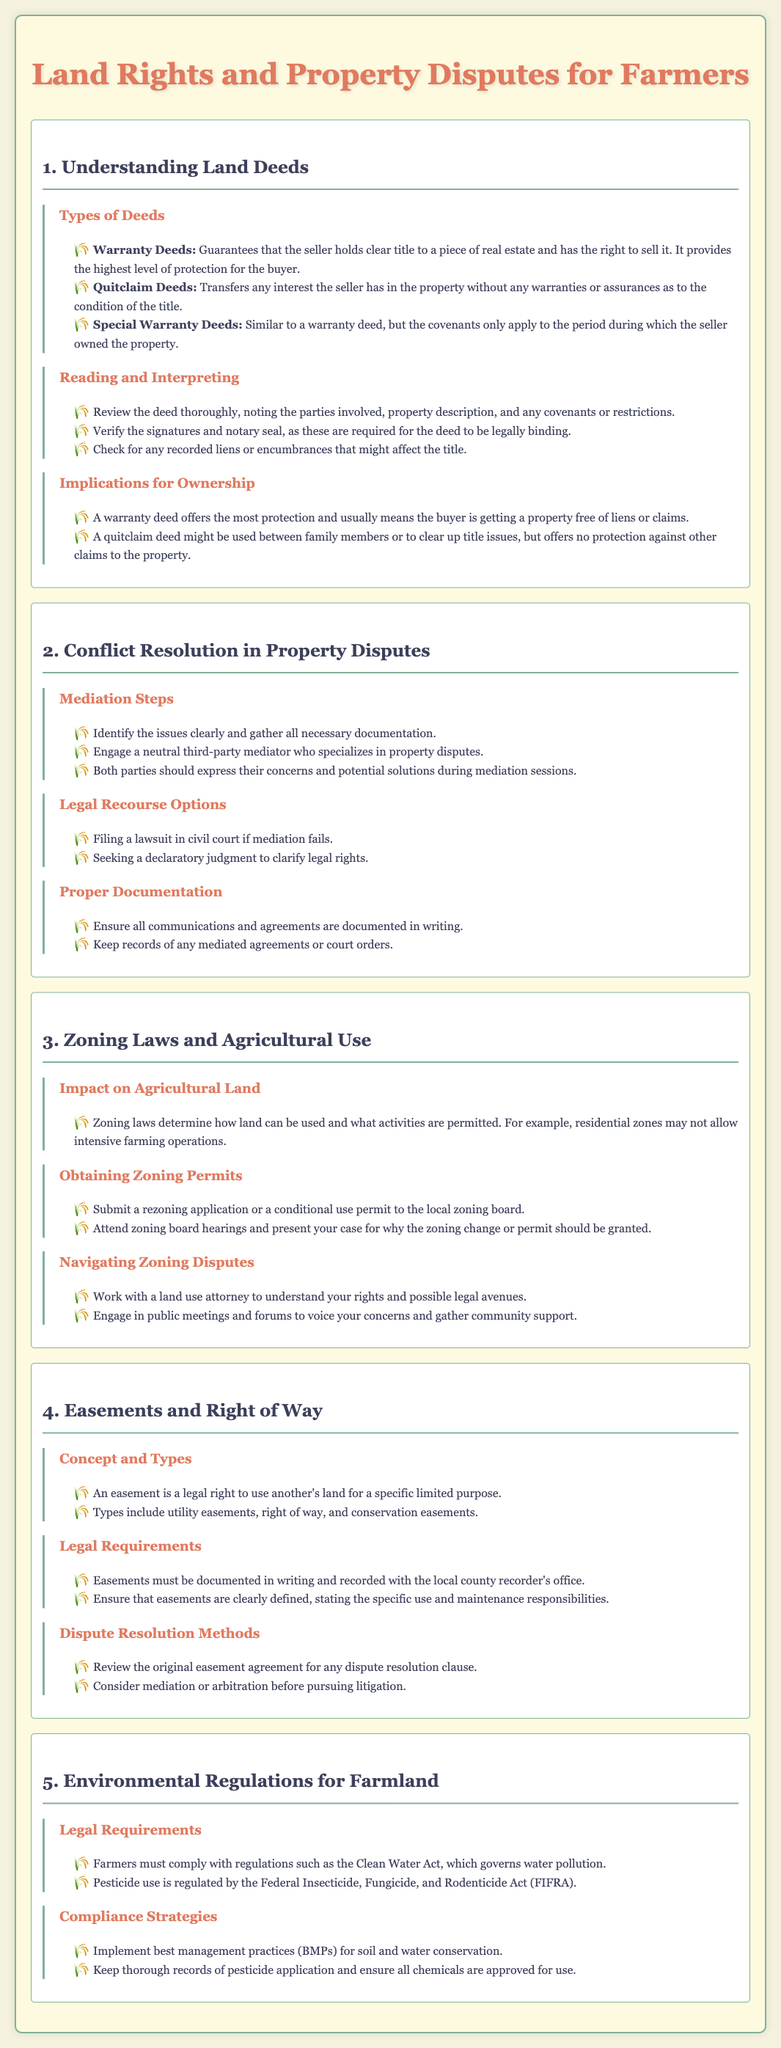What are the three types of deeds mentioned? The document lists warranty deeds, quitclaim deeds, and special warranty deeds as the three types of deeds.
Answer: warranty deeds, quitclaim deeds, special warranty deeds What is a warranty deed? A warranty deed guarantees that the seller holds clear title to a piece of real estate and has the right to sell it.
Answer: Guarantees clear title What steps are involved in mediation? The document outlines identifying issues, engaging a mediator, and expressing concerns as mediation steps.
Answer: Identify issues, engage mediator, express concerns Which act governs pesticide use? The document states that the Federal Insecticide, Fungicide, and Rodenticide Act (FIFRA) regulates pesticide use.
Answer: FIFRA What should all communications and agreements be? The lesson plan emphasizes that all communications and agreements should be documented in writing.
Answer: Documented in writing What is the first step to obtain zoning permits? The document indicates that submitting a rezoning application or a conditional use permit is the first step to obtain zoning permits.
Answer: Submit rezoning application How can disputes over easements be resolved? The document mentions reviewing the original easement agreement and considering mediation or arbitration as dispute resolution methods.
Answer: Mediation or arbitration What legal requirement is mentioned for easements? The document specifies that easements must be documented in writing and recorded with the local county recorder's office.
Answer: Documented in writing Which law relates to maintaining environmental standards in farmland? The document states that farmers must comply with the Clean Water Act, which governs water pollution.
Answer: Clean Water Act 